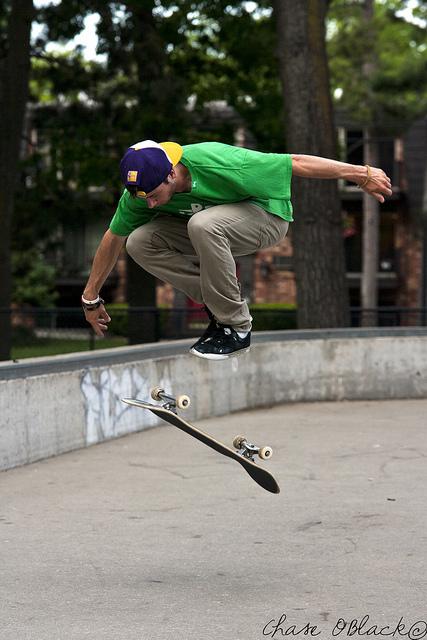What color are the man's shoes?
Quick response, please. Black. Is the man's shirt green?
Keep it brief. Yes. Where is the man skateboarding?
Give a very brief answer. Park. 